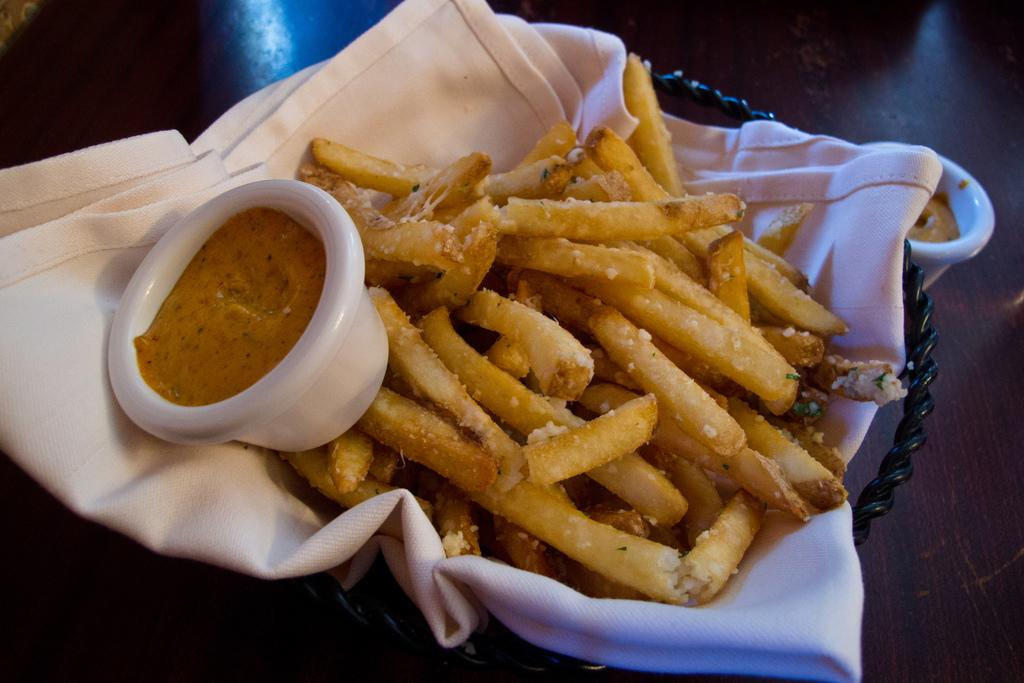What type of food can be seen in the image? The food in the image is in brown color. How is the food placed in the image? The food is on a cloth in the image. What color is the cloth? The cloth is in white color. What other object can be seen in the image? There is a bowl in the image. What color is the bowl? The bowl is in white color. How do the geese express their anger in the image? There are no geese present in the image, so it is not possible to determine how they might express anger. 